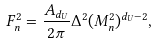Convert formula to latex. <formula><loc_0><loc_0><loc_500><loc_500>F _ { n } ^ { 2 } = \frac { A _ { d _ { U } } } { 2 \pi } \Delta ^ { 2 } ( M _ { n } ^ { 2 } ) ^ { d _ { U } - 2 } ,</formula> 